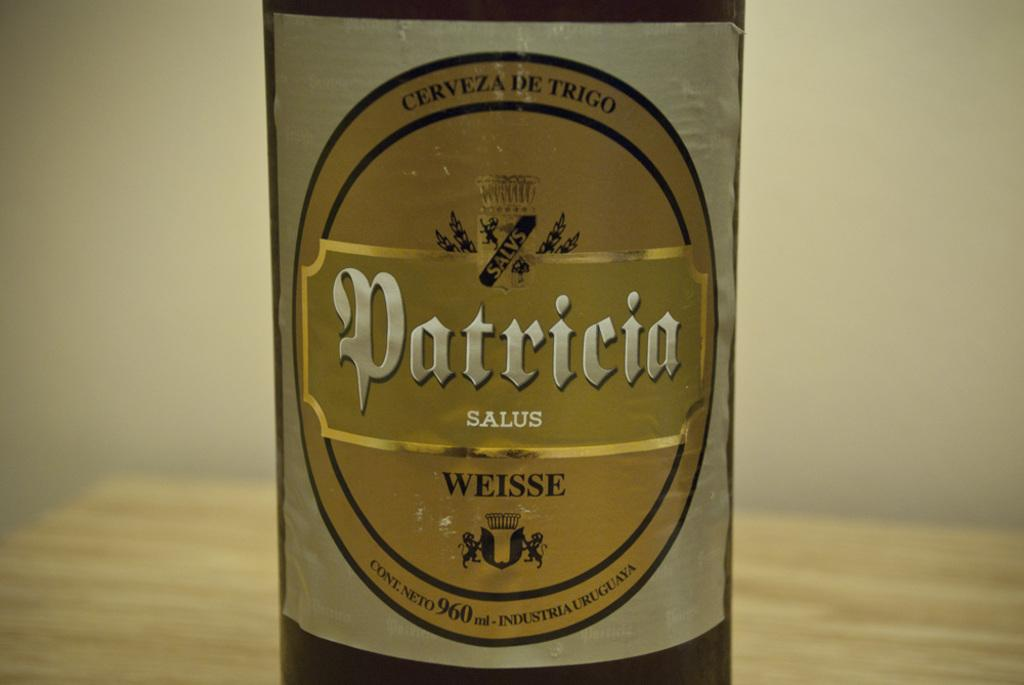Provide a one-sentence caption for the provided image. The female name Patricia is also the name of a brand of imported beer. 